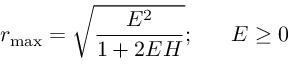<formula> <loc_0><loc_0><loc_500><loc_500>r _ { \max } = \sqrt { \frac { E ^ { 2 } } { 1 + 2 E H } } ; \, E \geq 0</formula> 